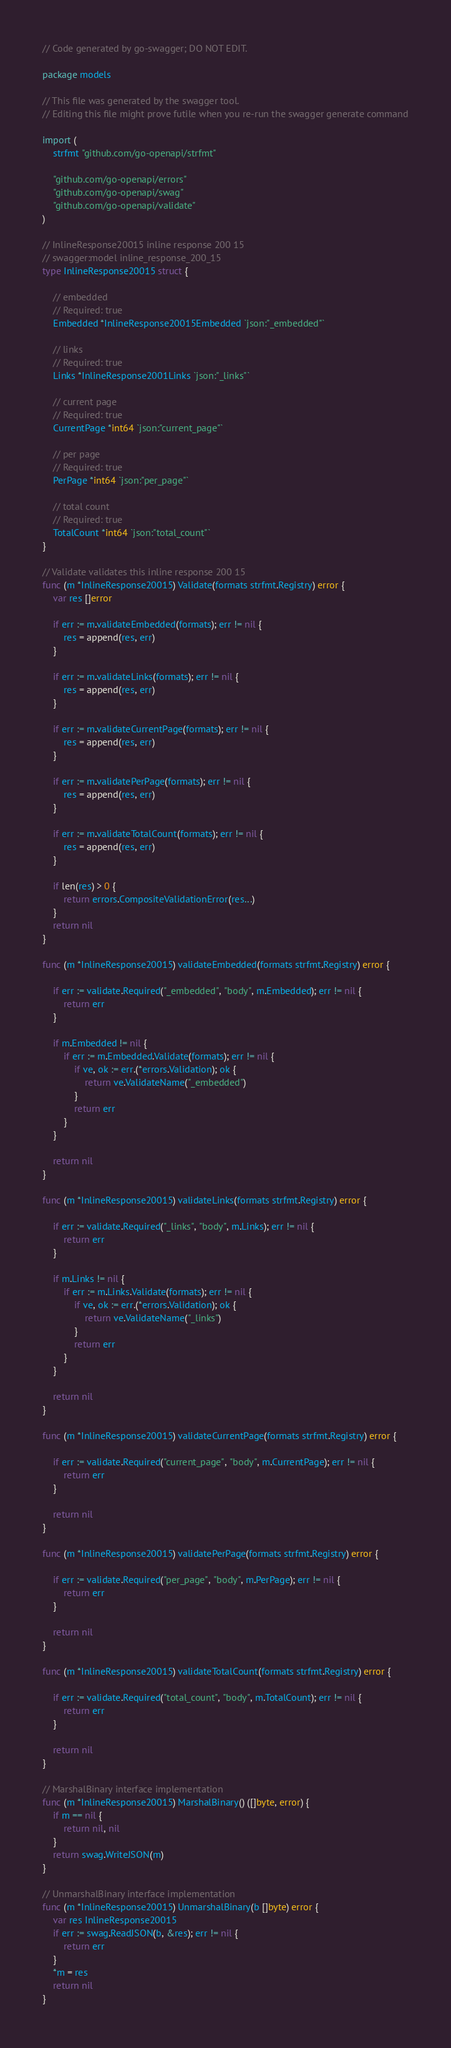<code> <loc_0><loc_0><loc_500><loc_500><_Go_>// Code generated by go-swagger; DO NOT EDIT.

package models

// This file was generated by the swagger tool.
// Editing this file might prove futile when you re-run the swagger generate command

import (
	strfmt "github.com/go-openapi/strfmt"

	"github.com/go-openapi/errors"
	"github.com/go-openapi/swag"
	"github.com/go-openapi/validate"
)

// InlineResponse20015 inline response 200 15
// swagger:model inline_response_200_15
type InlineResponse20015 struct {

	// embedded
	// Required: true
	Embedded *InlineResponse20015Embedded `json:"_embedded"`

	// links
	// Required: true
	Links *InlineResponse2001Links `json:"_links"`

	// current page
	// Required: true
	CurrentPage *int64 `json:"current_page"`

	// per page
	// Required: true
	PerPage *int64 `json:"per_page"`

	// total count
	// Required: true
	TotalCount *int64 `json:"total_count"`
}

// Validate validates this inline response 200 15
func (m *InlineResponse20015) Validate(formats strfmt.Registry) error {
	var res []error

	if err := m.validateEmbedded(formats); err != nil {
		res = append(res, err)
	}

	if err := m.validateLinks(formats); err != nil {
		res = append(res, err)
	}

	if err := m.validateCurrentPage(formats); err != nil {
		res = append(res, err)
	}

	if err := m.validatePerPage(formats); err != nil {
		res = append(res, err)
	}

	if err := m.validateTotalCount(formats); err != nil {
		res = append(res, err)
	}

	if len(res) > 0 {
		return errors.CompositeValidationError(res...)
	}
	return nil
}

func (m *InlineResponse20015) validateEmbedded(formats strfmt.Registry) error {

	if err := validate.Required("_embedded", "body", m.Embedded); err != nil {
		return err
	}

	if m.Embedded != nil {
		if err := m.Embedded.Validate(formats); err != nil {
			if ve, ok := err.(*errors.Validation); ok {
				return ve.ValidateName("_embedded")
			}
			return err
		}
	}

	return nil
}

func (m *InlineResponse20015) validateLinks(formats strfmt.Registry) error {

	if err := validate.Required("_links", "body", m.Links); err != nil {
		return err
	}

	if m.Links != nil {
		if err := m.Links.Validate(formats); err != nil {
			if ve, ok := err.(*errors.Validation); ok {
				return ve.ValidateName("_links")
			}
			return err
		}
	}

	return nil
}

func (m *InlineResponse20015) validateCurrentPage(formats strfmt.Registry) error {

	if err := validate.Required("current_page", "body", m.CurrentPage); err != nil {
		return err
	}

	return nil
}

func (m *InlineResponse20015) validatePerPage(formats strfmt.Registry) error {

	if err := validate.Required("per_page", "body", m.PerPage); err != nil {
		return err
	}

	return nil
}

func (m *InlineResponse20015) validateTotalCount(formats strfmt.Registry) error {

	if err := validate.Required("total_count", "body", m.TotalCount); err != nil {
		return err
	}

	return nil
}

// MarshalBinary interface implementation
func (m *InlineResponse20015) MarshalBinary() ([]byte, error) {
	if m == nil {
		return nil, nil
	}
	return swag.WriteJSON(m)
}

// UnmarshalBinary interface implementation
func (m *InlineResponse20015) UnmarshalBinary(b []byte) error {
	var res InlineResponse20015
	if err := swag.ReadJSON(b, &res); err != nil {
		return err
	}
	*m = res
	return nil
}
</code> 